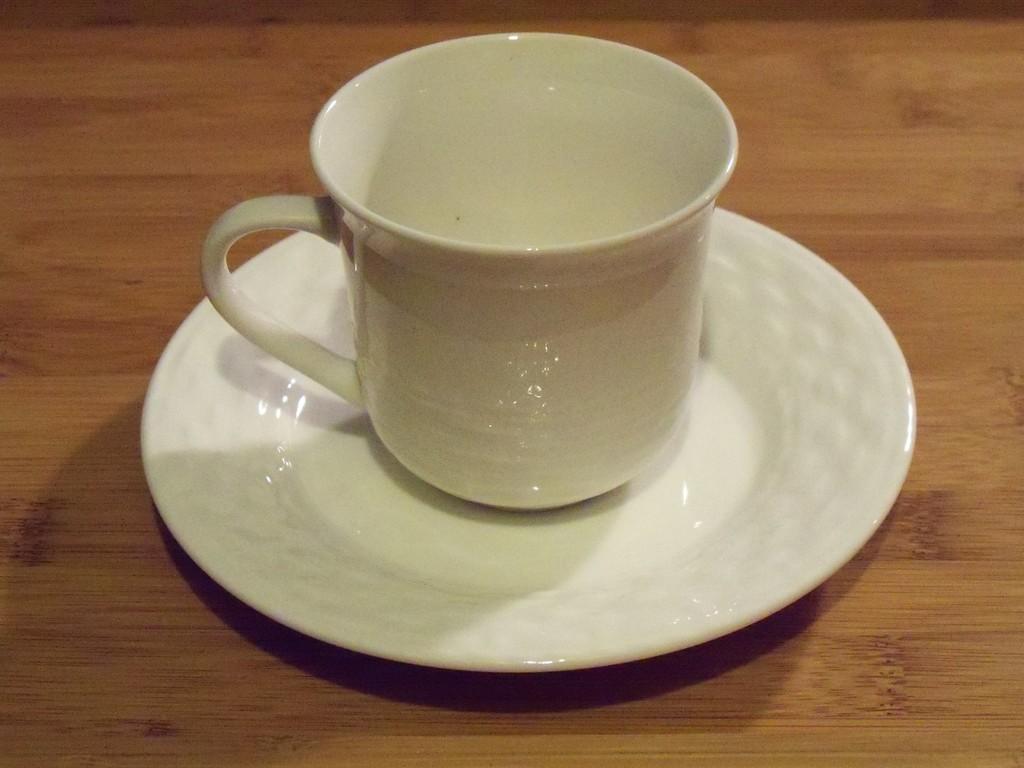Please provide a concise description of this image. In this picture there is a empty cup which is in white color is placed on a saucer. 